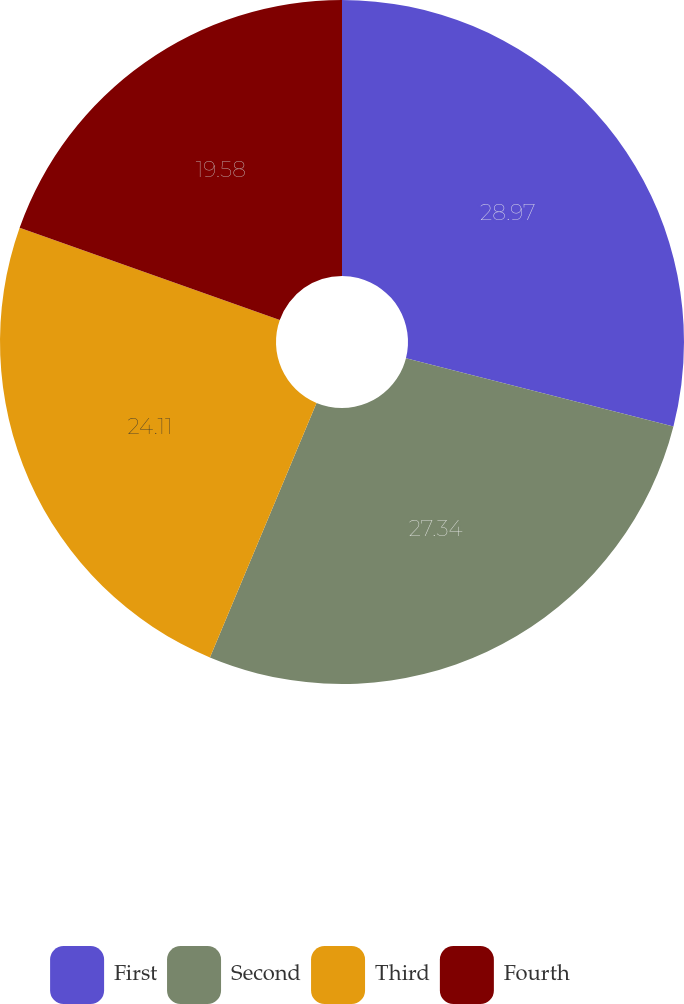Convert chart to OTSL. <chart><loc_0><loc_0><loc_500><loc_500><pie_chart><fcel>First<fcel>Second<fcel>Third<fcel>Fourth<nl><fcel>28.97%<fcel>27.34%<fcel>24.11%<fcel>19.58%<nl></chart> 